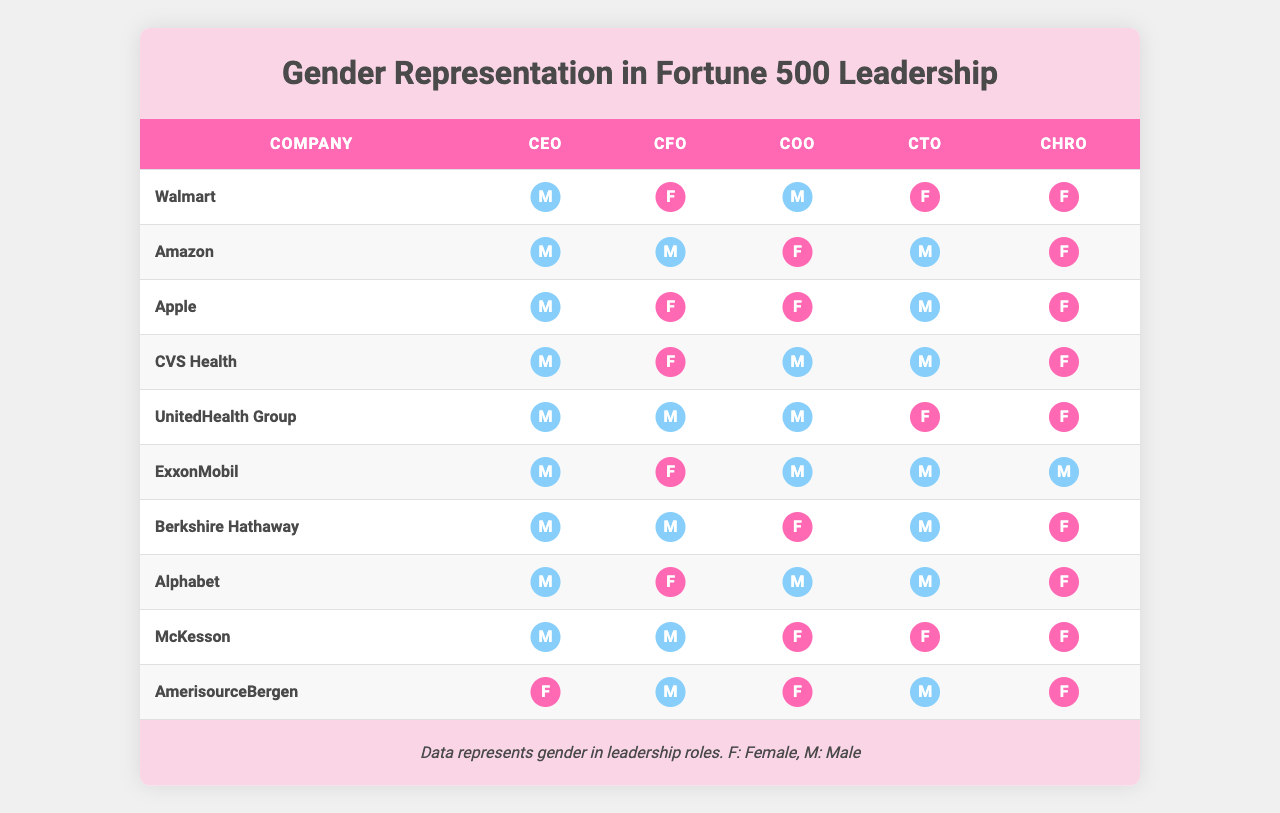What is the total number of female CEOs among the listed companies? By examining the "CEO" column, we see that there is only one company with a female CEO (AmerisourceBergen), which has a value of 1 while the others have 0. Therefore, the total is 1.
Answer: 1 How many companies have female CFOs? In the "CFO" column, we count the number of companies that have a value of 1 (indicating a female CFO). Those companies are Walmart, Apple, CVS Health, ExxonMobil, Alphabet. This totals to 5 companies.
Answer: 5 Which company has the highest number of female representation in leadership roles? To determine this, we need to count the total number of leadership roles filled by females for each company. AmerisourceBergen has 4 female leaders, while Walmart, Apple, CVS Health, and UnitedHealth Group have 3 each. AmerisourceBergen has the highest count.
Answer: AmerisourceBergen Are there more companies with female CHROs than male CHROs? By examining the "CHRO" column, we identify that 6 companies have a value of 1 for female CHROs, while 4 companies show male CHROs (value 0). Therefore, there are more female CHROs.
Answer: Yes What fraction of companies have at least one female in leadership positions (CEO, CFO, COO, CTO, or CHRO)? First, we identify companies that have any female in leadership. Counting those reveals 10 companies in total, and all 10 companies have at least one role filled by a female. Thus, the fraction is 10/10, which simplifies to 1.
Answer: 1 Which position has the highest male representation across these companies? To find this, we must count the number of '0's in each position column (indicating male representation). The counts are 10 for CEO, 5 for CFO, 6 for COO, 8 for CTO, and 4 for CHRO. The CEO position has the highest count of 10.
Answer: CEO Is there a company that has only male leaders in all executive positions? Checking each company, we see that there are no companies listed with all male leaders. In fact, AmerisourceBergen is the only company with a female leader in any position. Hence, the statement is false.
Answer: No How many roles are filled by females in the company with the least female representation? We check each company for the total female representation in leadership roles. The company with the least female representation is ExxonMobil, with only 1 role (CFO) filled by a female.
Answer: 1 What percentage of companies have a female COO? There are 4 companies with the COO role filled by a female, out of 10 total companies. Calculating the percentage gives (4/10) * 100 = 40%.
Answer: 40% Which companies do not have a female CEO or CTO? Examining the table, there are several companies without a female in these positions: Walmart, Amazon, ExxonMobil, and Alphabet. These companies represent the exclusion criteria for both CEO and CTO roles.
Answer: Walmart, Amazon, ExxonMobil, Alphabet 